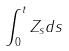<formula> <loc_0><loc_0><loc_500><loc_500>\int _ { 0 } ^ { t } Z _ { s } d s</formula> 